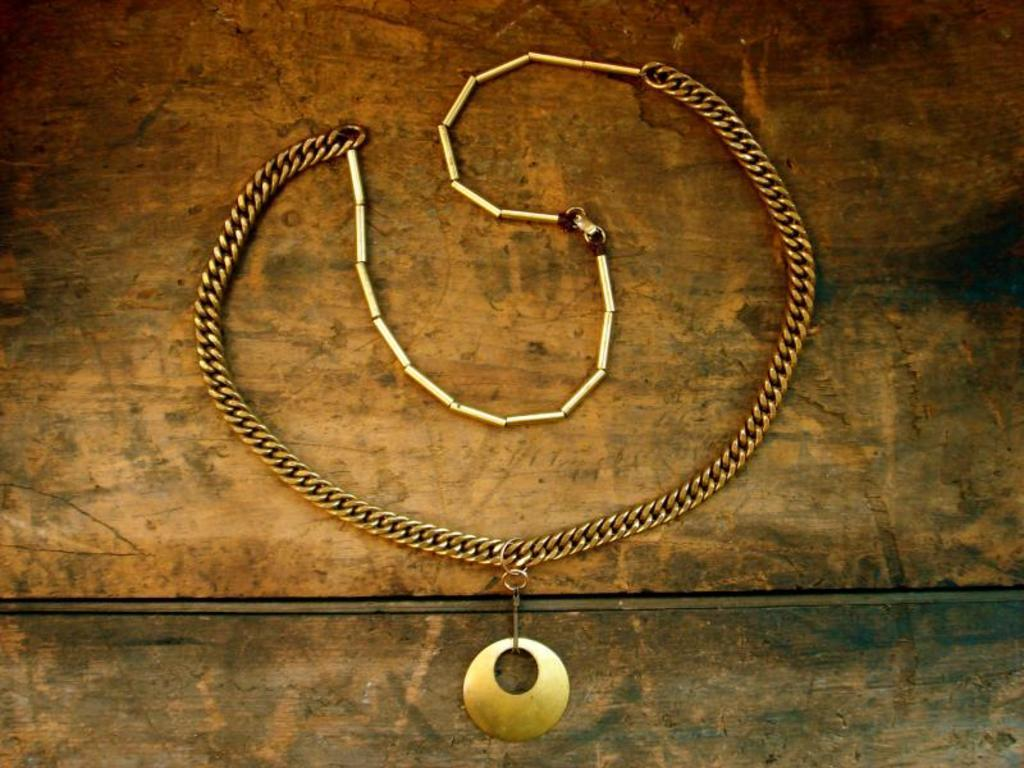What type of jewelry is visible in the image? There is a necklace with a pendant in the image. Where is the necklace located? The necklace is on a wooden table. Can you see the seashore in the image? No, there is no seashore present in the image. What wish does the pendant on the necklace grant? The image does not provide any information about the pendant's ability to grant wishes. 